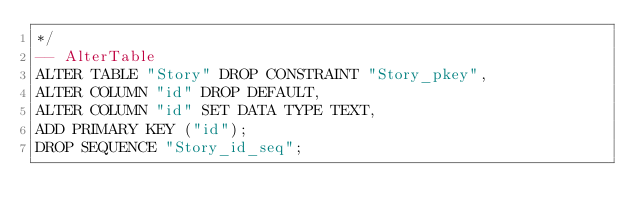<code> <loc_0><loc_0><loc_500><loc_500><_SQL_>*/
-- AlterTable
ALTER TABLE "Story" DROP CONSTRAINT "Story_pkey",
ALTER COLUMN "id" DROP DEFAULT,
ALTER COLUMN "id" SET DATA TYPE TEXT,
ADD PRIMARY KEY ("id");
DROP SEQUENCE "Story_id_seq";
</code> 